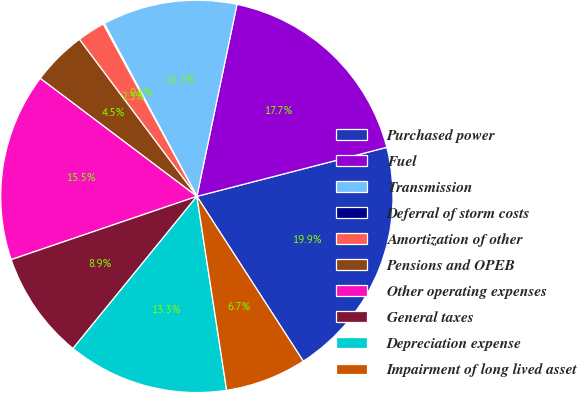Convert chart. <chart><loc_0><loc_0><loc_500><loc_500><pie_chart><fcel>Purchased power<fcel>Fuel<fcel>Transmission<fcel>Deferral of storm costs<fcel>Amortization of other<fcel>Pensions and OPEB<fcel>Other operating expenses<fcel>General taxes<fcel>Depreciation expense<fcel>Impairment of long lived asset<nl><fcel>19.9%<fcel>17.7%<fcel>11.1%<fcel>0.1%<fcel>2.3%<fcel>4.5%<fcel>15.5%<fcel>8.9%<fcel>13.3%<fcel>6.7%<nl></chart> 